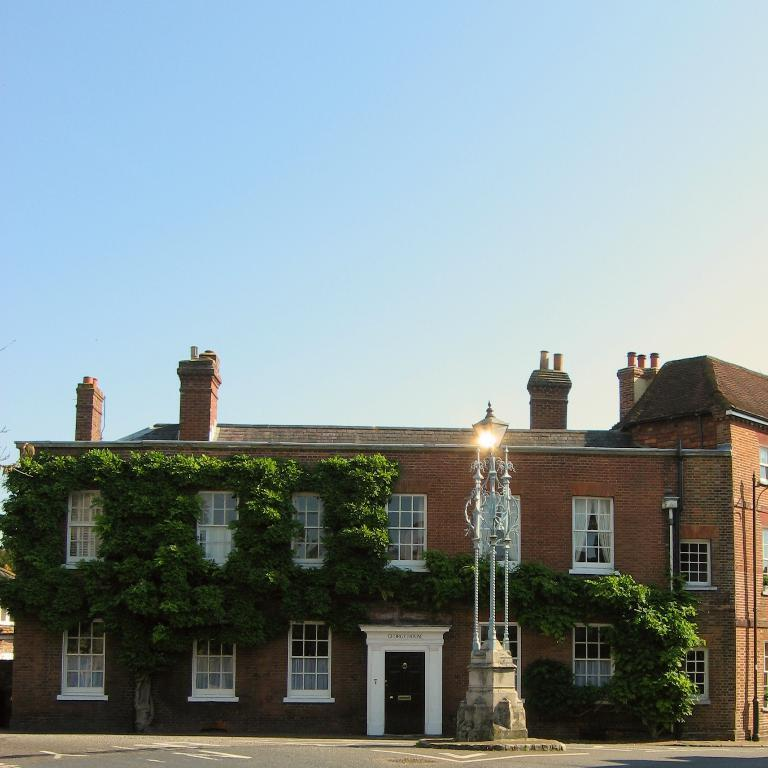What type of surface is visible in the image? There is a pavement in the image. What can be seen in the background of the image? There is a light pole, a building, and the sky visible in the background of the image. What features can be observed on the building? The building has windows and is associated with plants. What type of desk is visible in the image? There is no desk present in the image. How do the roots of the plants affect the appearance of the building in the image? There is no mention of roots in the image, as the plants are associated with the building but not shown in detail. 